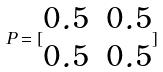<formula> <loc_0><loc_0><loc_500><loc_500>P = [ \begin{matrix} 0 . 5 & 0 . 5 \\ 0 . 5 & 0 . 5 \\ \end{matrix} ]</formula> 